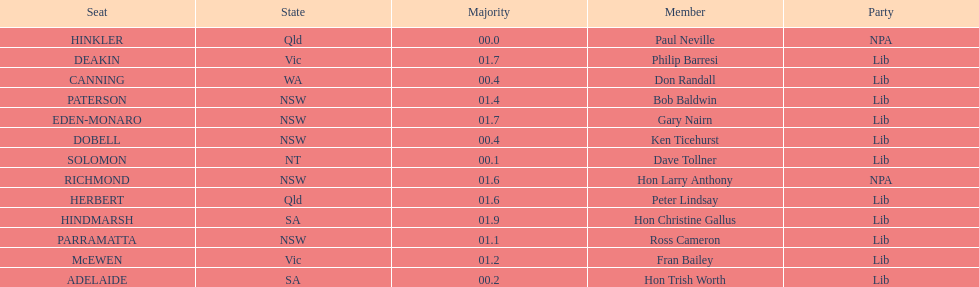How many states were represented in the seats? 6. Would you be able to parse every entry in this table? {'header': ['Seat', 'State', 'Majority', 'Member', 'Party'], 'rows': [['HINKLER', 'Qld', '00.0', 'Paul Neville', 'NPA'], ['DEAKIN', 'Vic', '01.7', 'Philip Barresi', 'Lib'], ['CANNING', 'WA', '00.4', 'Don Randall', 'Lib'], ['PATERSON', 'NSW', '01.4', 'Bob Baldwin', 'Lib'], ['EDEN-MONARO', 'NSW', '01.7', 'Gary Nairn', 'Lib'], ['DOBELL', 'NSW', '00.4', 'Ken Ticehurst', 'Lib'], ['SOLOMON', 'NT', '00.1', 'Dave Tollner', 'Lib'], ['RICHMOND', 'NSW', '01.6', 'Hon Larry Anthony', 'NPA'], ['HERBERT', 'Qld', '01.6', 'Peter Lindsay', 'Lib'], ['HINDMARSH', 'SA', '01.9', 'Hon Christine Gallus', 'Lib'], ['PARRAMATTA', 'NSW', '01.1', 'Ross Cameron', 'Lib'], ['McEWEN', 'Vic', '01.2', 'Fran Bailey', 'Lib'], ['ADELAIDE', 'SA', '00.2', 'Hon Trish Worth', 'Lib']]} 